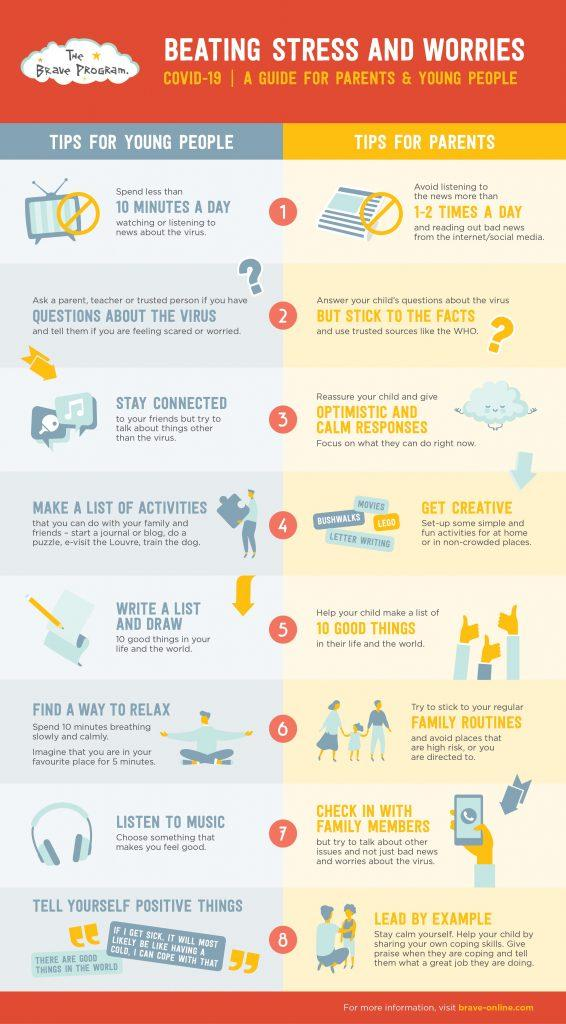Specify some key components in this picture. When attempting to relax, one should visualize themselves in their most preferred location. Eight tips have been provided for both young people and parents. Other than letter writing, there are various creative ideas such as bushwalks, Lego, and movies that can be pursued to enhance one's interests and passions. It is recommended to listen to the news 1-2 times a day. 